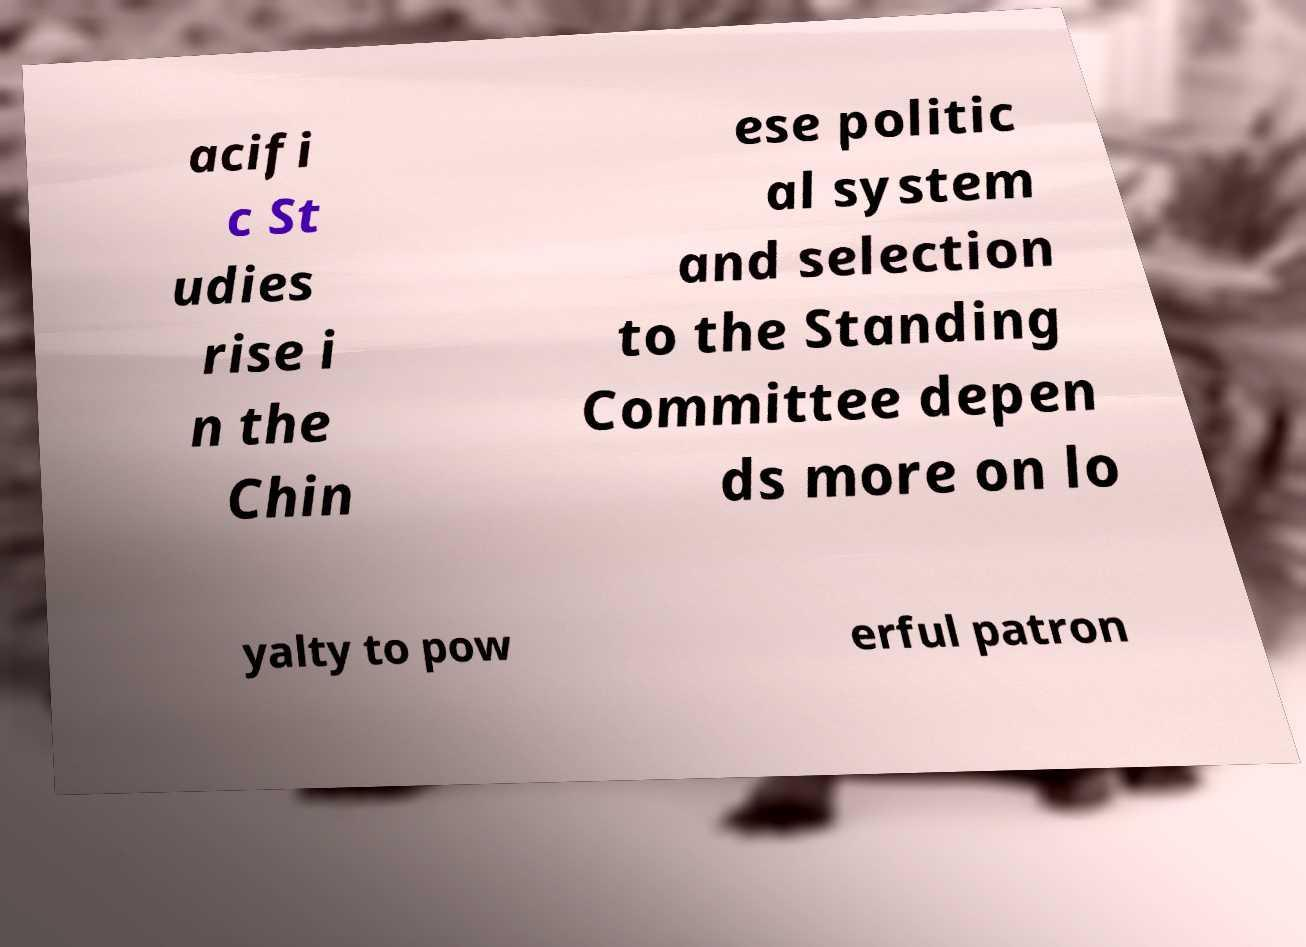There's text embedded in this image that I need extracted. Can you transcribe it verbatim? acifi c St udies rise i n the Chin ese politic al system and selection to the Standing Committee depen ds more on lo yalty to pow erful patron 